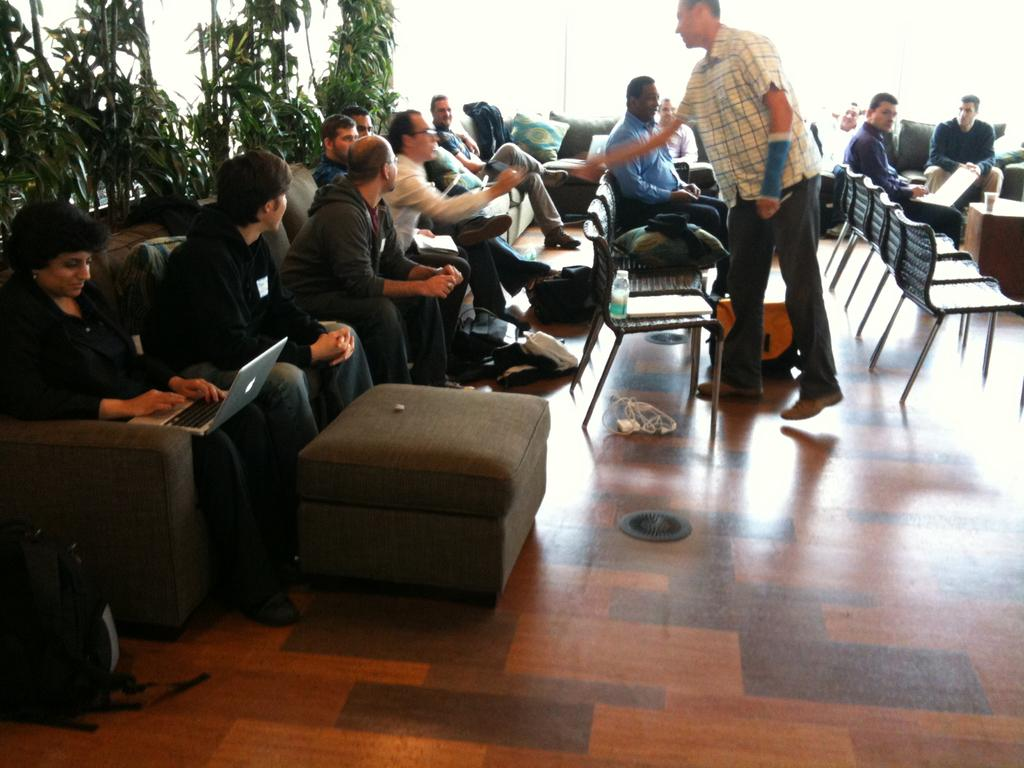How many people are sitting on the chair in the image? There is a group of people sitting on a chair in the image. What is the position of the person in the center? There is a person standing in the center of the image. What can be seen in the background of the image? There are plants visible in the background of the image. What type of knife is being used to cut the bread in the image? There is no knife or bread present in the image. How many marks are visible on the person standing in the center? There are no marks visible on the person standing in the center, as the image does not show any marks. 